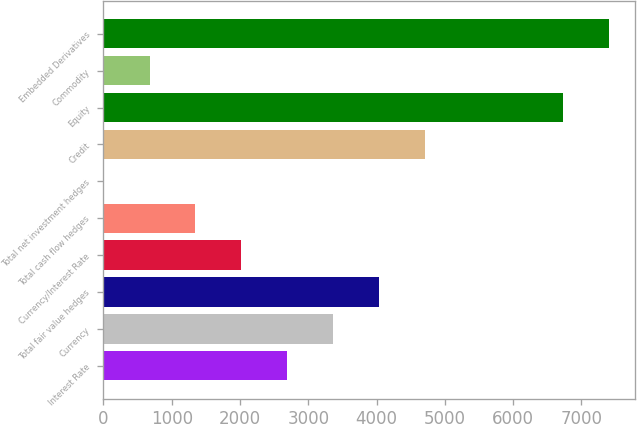Convert chart to OTSL. <chart><loc_0><loc_0><loc_500><loc_500><bar_chart><fcel>Interest Rate<fcel>Currency<fcel>Total fair value hedges<fcel>Currency/Interest Rate<fcel>Total cash flow hedges<fcel>Total net investment hedges<fcel>Credit<fcel>Equity<fcel>Commodity<fcel>Embedded Derivatives<nl><fcel>2694.06<fcel>3367.39<fcel>4040.72<fcel>2020.73<fcel>1347.4<fcel>0.74<fcel>4714.05<fcel>6734.04<fcel>674.07<fcel>7407.37<nl></chart> 